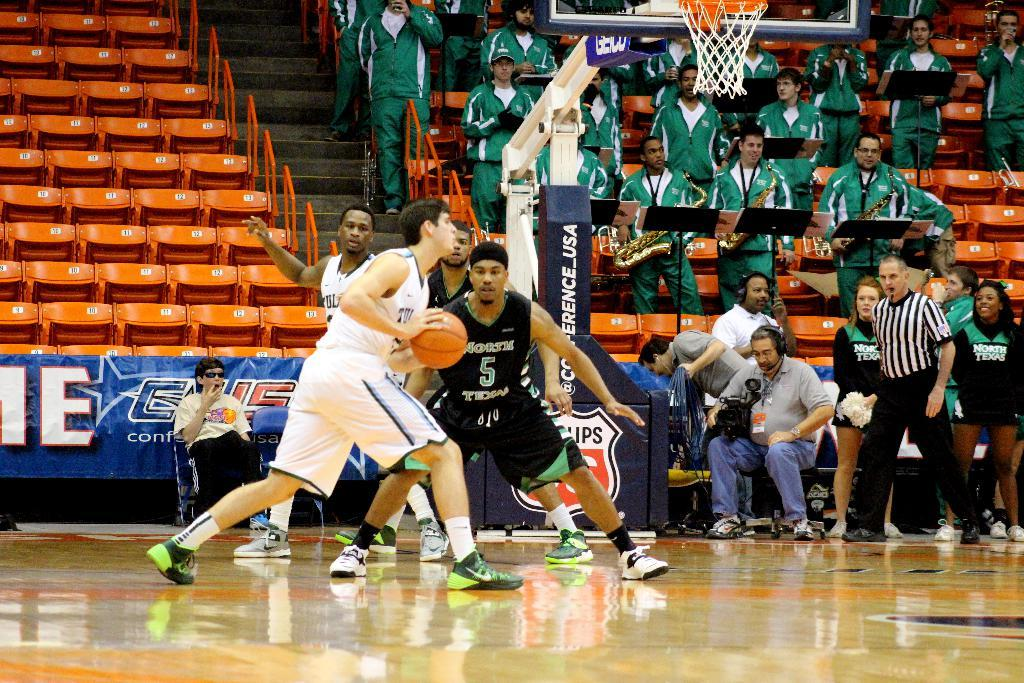<image>
Describe the image concisely. Player number 5 for the North Tides try's to steal the ball from his opponent 